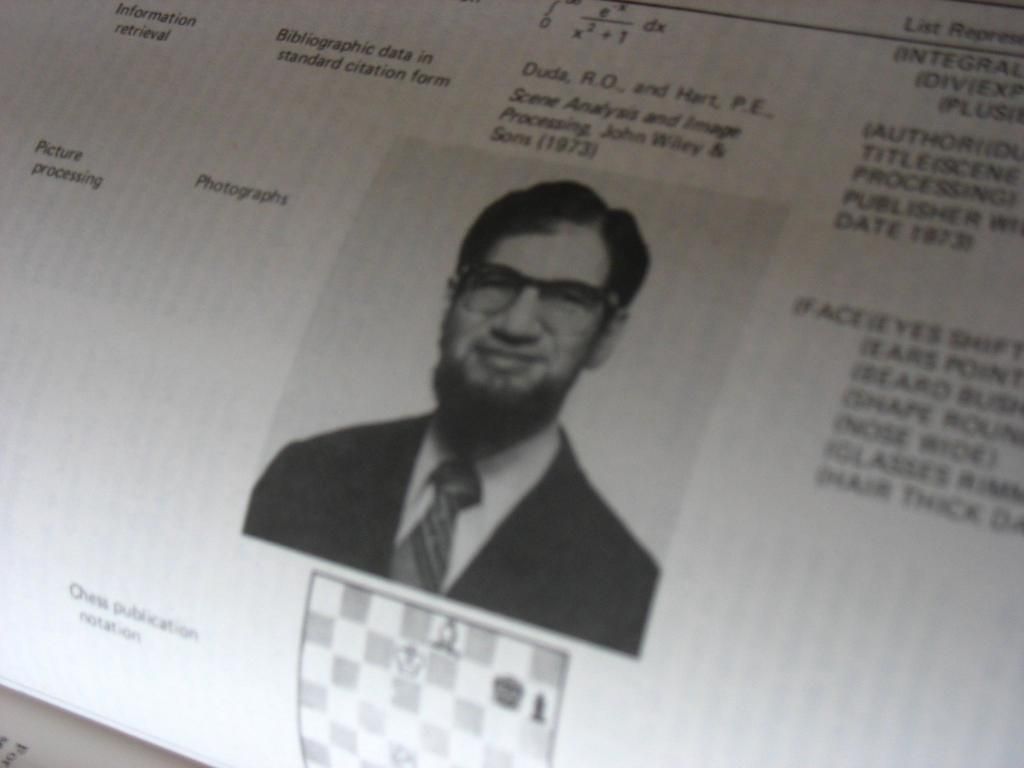What is located in the foreground of the image? There is a folded paper in the foreground of the image. What is depicted on the paper? There is an image of a man on the paper. What else can be seen on the paper besides the image of the man? There is text around the image of the man on the paper. What type of rings can be seen on the man's fingers in the image? There are no rings visible on the man's fingers in the image, as the image only shows the man's face and not his hands. 